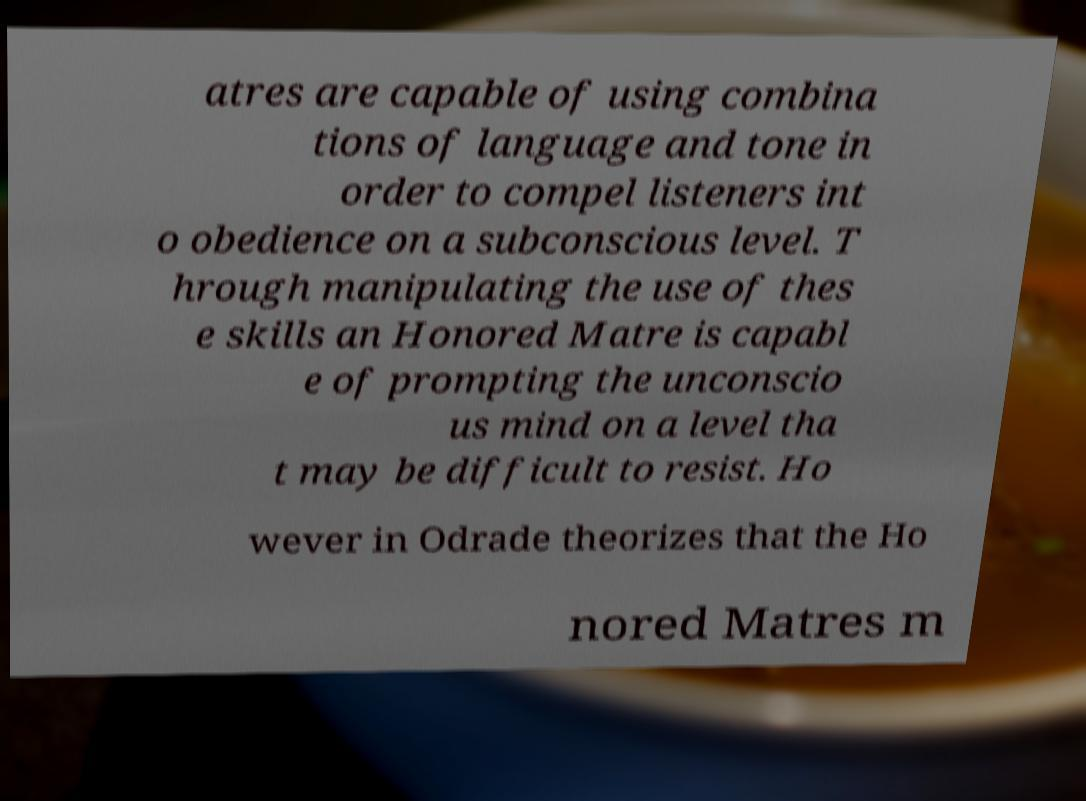For documentation purposes, I need the text within this image transcribed. Could you provide that? atres are capable of using combina tions of language and tone in order to compel listeners int o obedience on a subconscious level. T hrough manipulating the use of thes e skills an Honored Matre is capabl e of prompting the unconscio us mind on a level tha t may be difficult to resist. Ho wever in Odrade theorizes that the Ho nored Matres m 